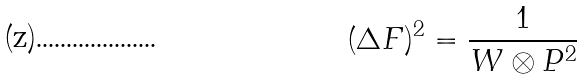<formula> <loc_0><loc_0><loc_500><loc_500>( \Delta F ) ^ { 2 } = \frac { 1 } { W \otimes P ^ { 2 } }</formula> 